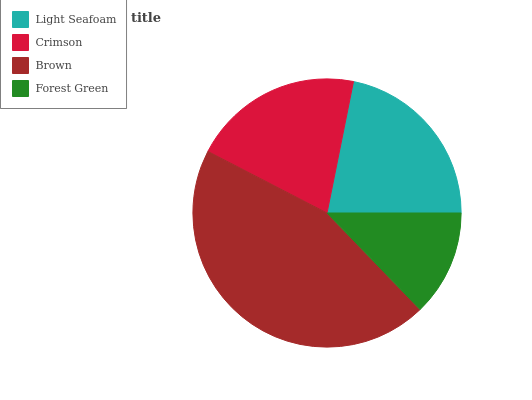Is Forest Green the minimum?
Answer yes or no. Yes. Is Brown the maximum?
Answer yes or no. Yes. Is Crimson the minimum?
Answer yes or no. No. Is Crimson the maximum?
Answer yes or no. No. Is Light Seafoam greater than Crimson?
Answer yes or no. Yes. Is Crimson less than Light Seafoam?
Answer yes or no. Yes. Is Crimson greater than Light Seafoam?
Answer yes or no. No. Is Light Seafoam less than Crimson?
Answer yes or no. No. Is Light Seafoam the high median?
Answer yes or no. Yes. Is Crimson the low median?
Answer yes or no. Yes. Is Crimson the high median?
Answer yes or no. No. Is Forest Green the low median?
Answer yes or no. No. 